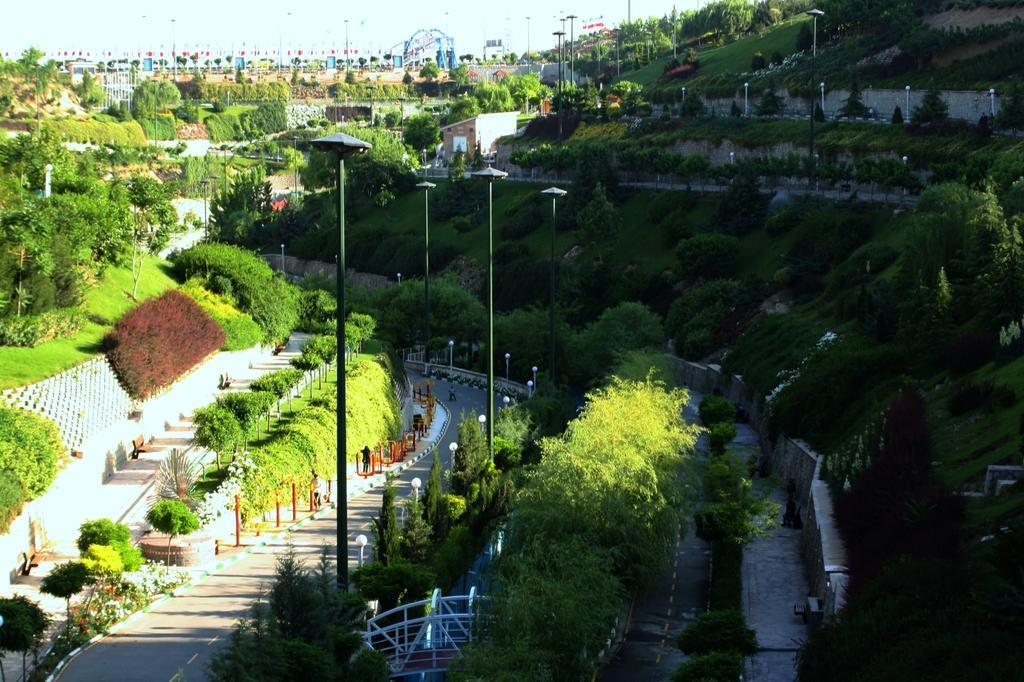How would you summarize this image in a sentence or two? In this image I can see the road. To the side of the road there are many trees and the poles. I can also see the railing to the side. In the background I can see few more trees, houses and the sky. 